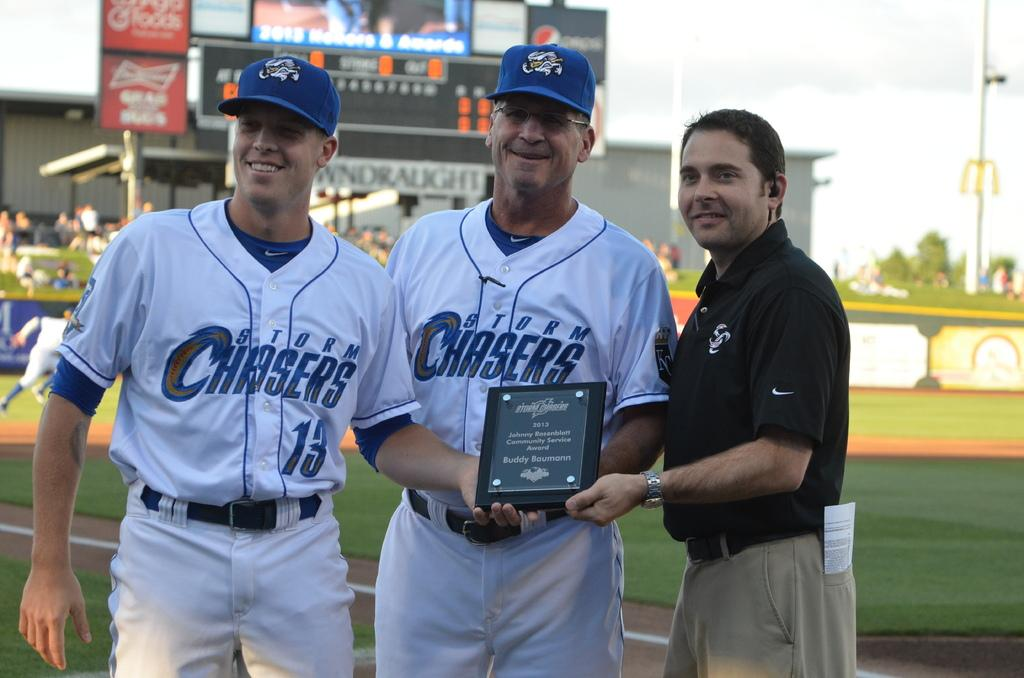<image>
Provide a brief description of the given image. 2013 Community Service Award reads the plaque being held by these Storm Chaser team members. 